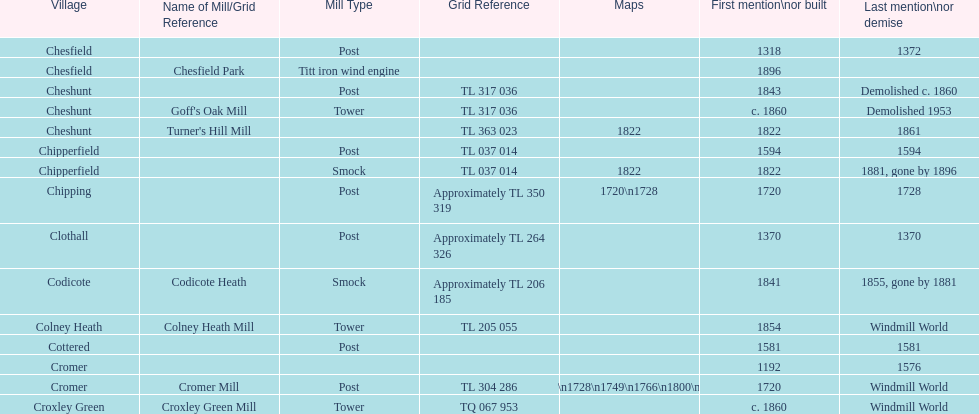How many mills were mentioned or built before 1700? 5. 